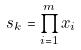<formula> <loc_0><loc_0><loc_500><loc_500>s _ { k } = \prod _ { i = 1 } ^ { m } x _ { i }</formula> 